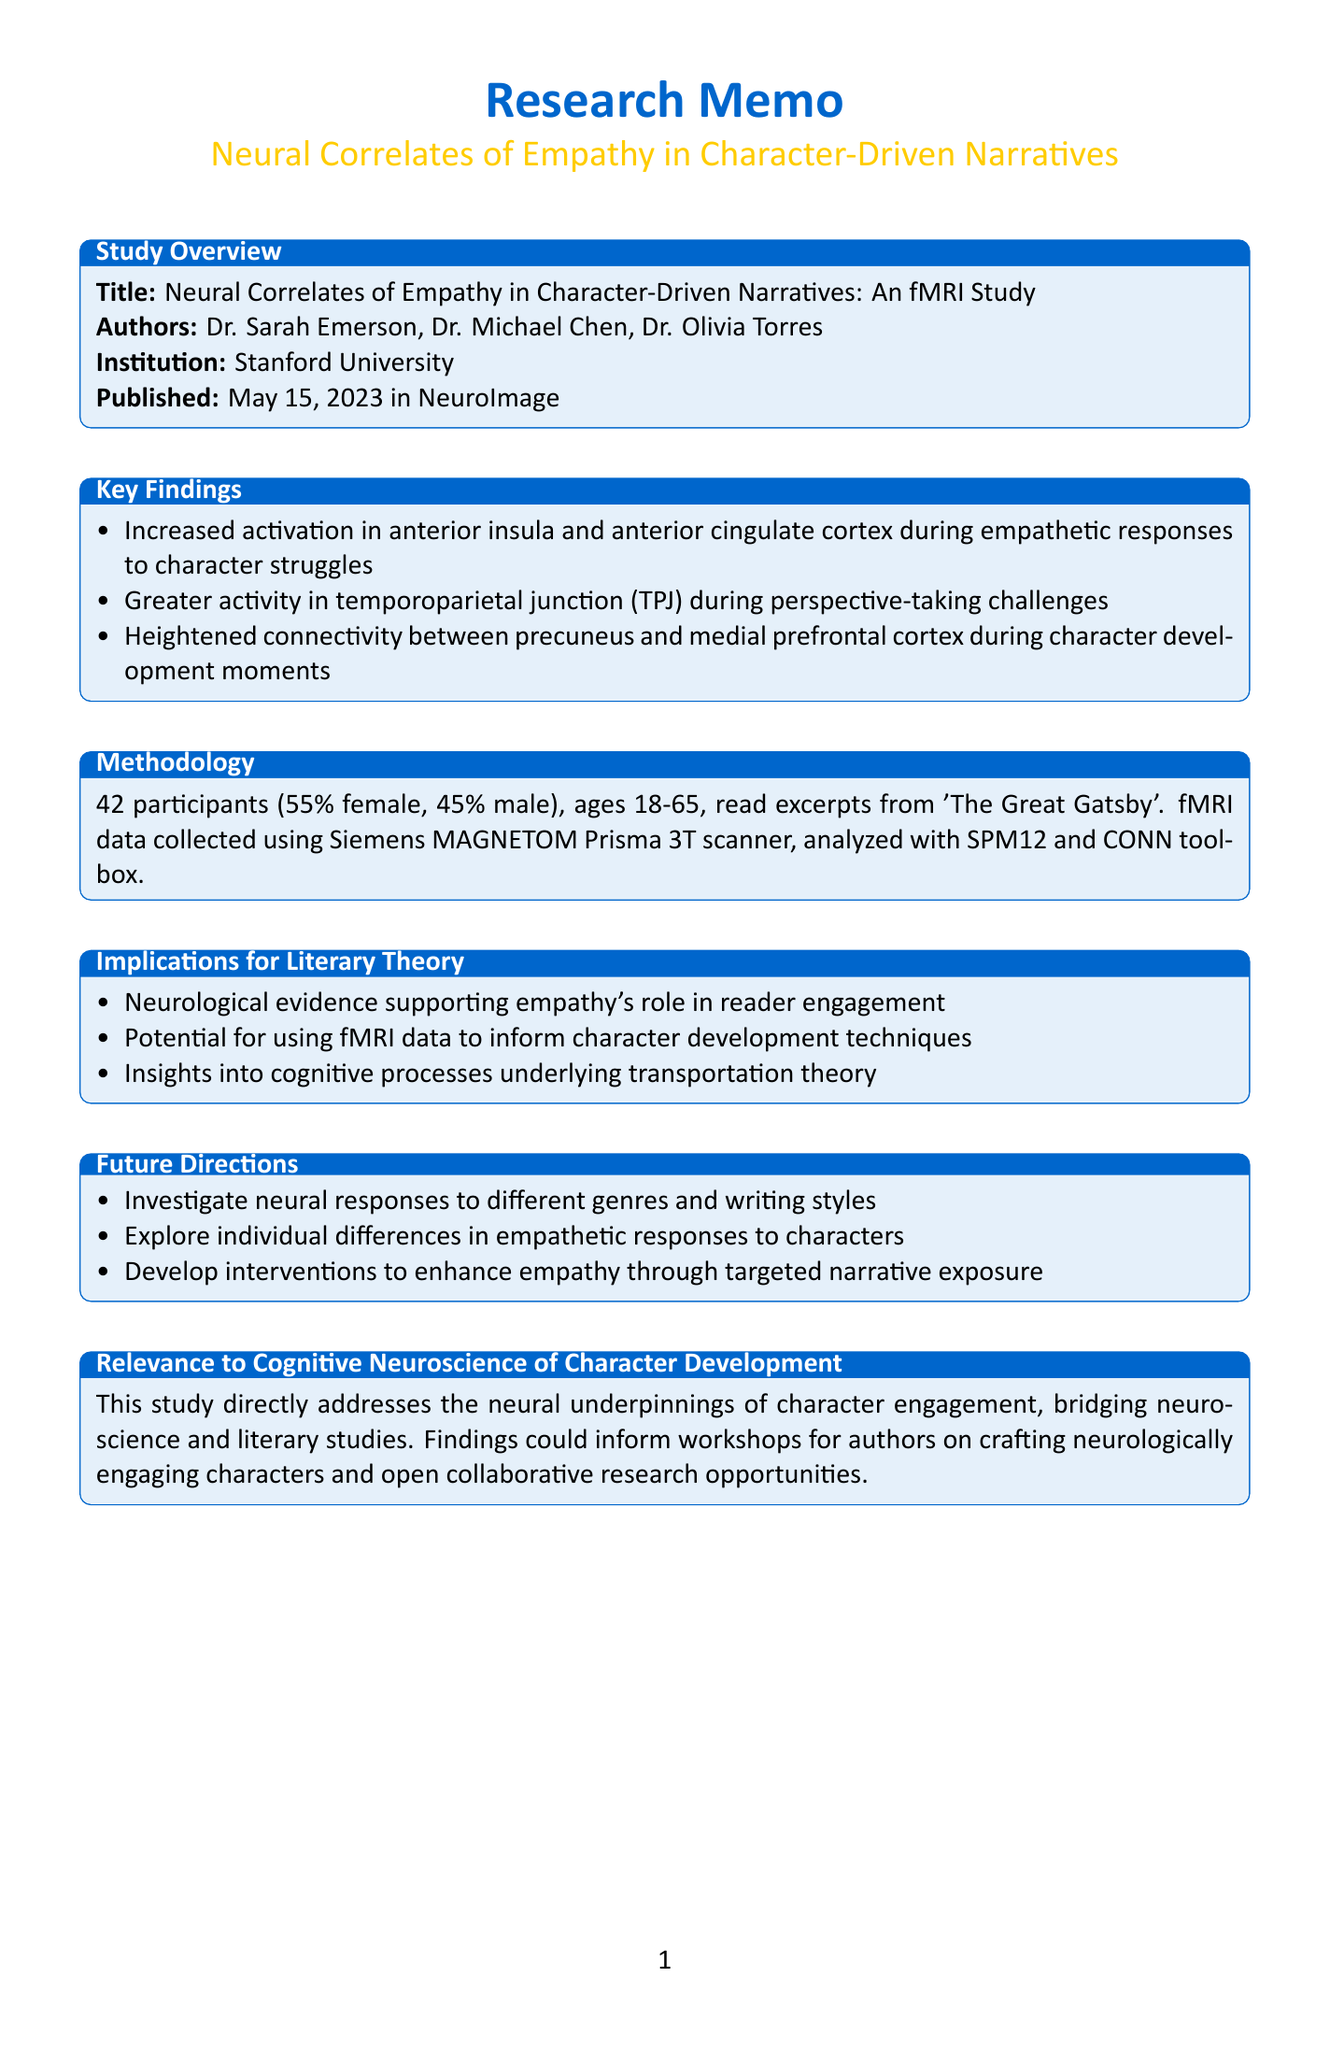What is the title of the study? The title of the study is explicitly stated in the "Study Overview" section.
Answer: Neural Correlates of Empathy in Character-Driven Narratives: An fMRI Study Who are the authors of the study? The authors are listed in the "Study Overview" section under authors.
Answer: Dr. Sarah Emerson, Dr. Michael Chen, Dr. Olivia Torres In which journal was the study published? The journal name appears in the "Study Overview" section of the document.
Answer: NeuroImage What was the sample size of participants in the study? The "Methodology" section provides the number of participants.
Answer: 42 What brain region showed increased activation during empathetic responses? The "Key Findings" section lists the specific brain region associated with empathetic responses.
Answer: anterior insula and anterior cingulate cortex What was the age range of participants? The "Methodology" section specifies the demographic details about participants' ages.
Answer: 18-65 How does this study compare to Mar et al. (2011)? The "Comparison With Previous Studies" section outlines differences between the studies.
Answer: Our study showed stronger activation in the anterior insula What future direction is suggested regarding individual differences? The "Future Directions" section proposes areas for further research exploration.
Answer: Explore individual differences in empathetic responses to characters What is one implication for literary theory mentioned in the document? The "Implications for Literary Theory" section outlines the relevance of findings for literary studies.
Answer: Neurological evidence supporting the role of empathy in reader engagement 